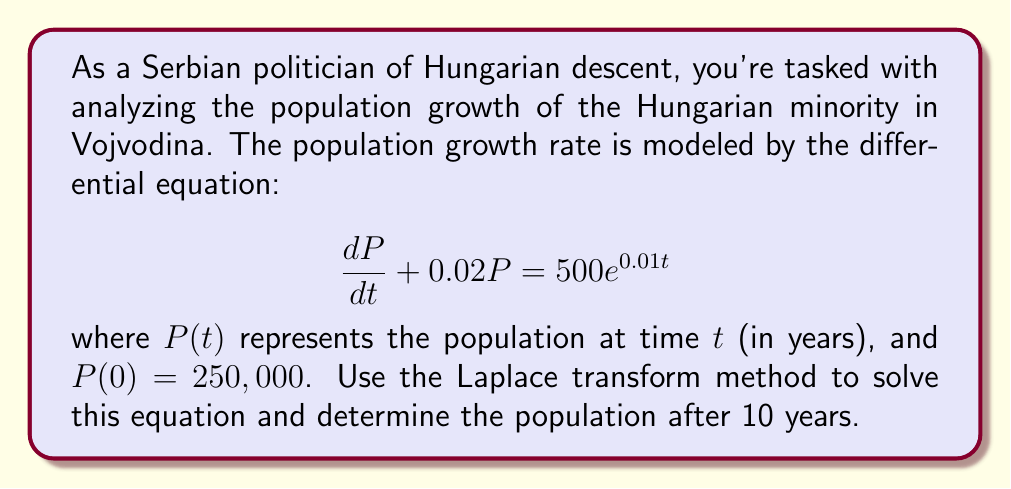Could you help me with this problem? 1) Take the Laplace transform of both sides of the equation:
   $$\mathcal{L}\{\frac{dP}{dt} + 0.02P\} = \mathcal{L}\{500e^{0.01t}\}$$

2) Using Laplace transform properties:
   $$sP(s) - P(0) + 0.02P(s) = \frac{500}{s-0.01}$$

3) Substitute $P(0) = 250,000$ and simplify:
   $$(s + 0.02)P(s) - 250,000 = \frac{500}{s-0.01}$$

4) Solve for $P(s)$:
   $$P(s) = \frac{250,000}{s + 0.02} + \frac{500}{(s + 0.02)(s - 0.01)}$$

5) Perform partial fraction decomposition:
   $$P(s) = \frac{250,000}{s + 0.02} + \frac{A}{s + 0.02} + \frac{B}{s - 0.01}$$
   where $A = -16,666.67$ and $B = 16,666.67$

6) Take the inverse Laplace transform:
   $$P(t) = 250,000e^{-0.02t} - 16,666.67e^{-0.02t} + 16,666.67e^{0.01t}$$

7) Simplify:
   $$P(t) = 233,333.33e^{-0.02t} + 16,666.67e^{0.01t}$$

8) To find the population after 10 years, substitute $t = 10$:
   $$P(10) = 233,333.33e^{-0.2} + 16,666.67e^{0.1}$$

9) Calculate the final result:
   $$P(10) \approx 191,166.67 + 18,419.49 = 209,586.16$$
Answer: 209,586 people 